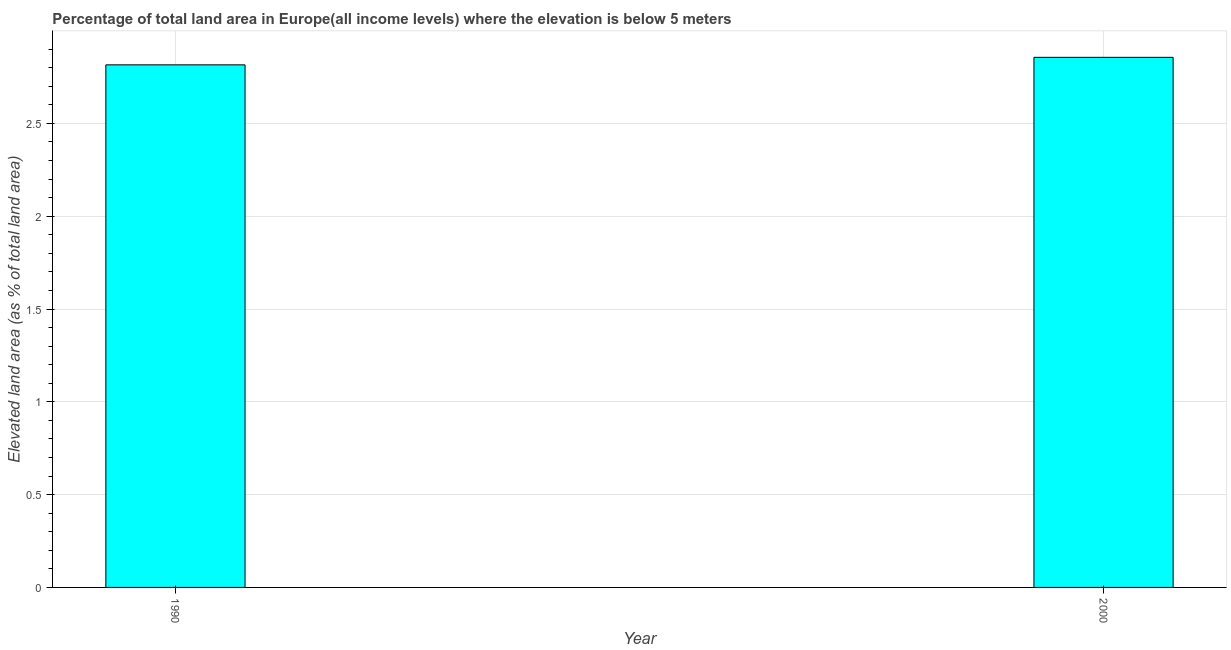What is the title of the graph?
Make the answer very short. Percentage of total land area in Europe(all income levels) where the elevation is below 5 meters. What is the label or title of the X-axis?
Your response must be concise. Year. What is the label or title of the Y-axis?
Your response must be concise. Elevated land area (as % of total land area). What is the total elevated land area in 1990?
Provide a succinct answer. 2.82. Across all years, what is the maximum total elevated land area?
Provide a short and direct response. 2.86. Across all years, what is the minimum total elevated land area?
Your response must be concise. 2.82. What is the sum of the total elevated land area?
Your response must be concise. 5.67. What is the difference between the total elevated land area in 1990 and 2000?
Make the answer very short. -0.04. What is the average total elevated land area per year?
Make the answer very short. 2.84. What is the median total elevated land area?
Offer a very short reply. 2.84. In how many years, is the total elevated land area greater than 0.1 %?
Keep it short and to the point. 2. Do a majority of the years between 1990 and 2000 (inclusive) have total elevated land area greater than 1.3 %?
Your answer should be very brief. Yes. In how many years, is the total elevated land area greater than the average total elevated land area taken over all years?
Your answer should be very brief. 1. How many bars are there?
Provide a short and direct response. 2. Are all the bars in the graph horizontal?
Give a very brief answer. No. How many years are there in the graph?
Your response must be concise. 2. What is the difference between two consecutive major ticks on the Y-axis?
Ensure brevity in your answer.  0.5. What is the Elevated land area (as % of total land area) of 1990?
Make the answer very short. 2.82. What is the Elevated land area (as % of total land area) in 2000?
Provide a succinct answer. 2.86. What is the difference between the Elevated land area (as % of total land area) in 1990 and 2000?
Offer a terse response. -0.04. 